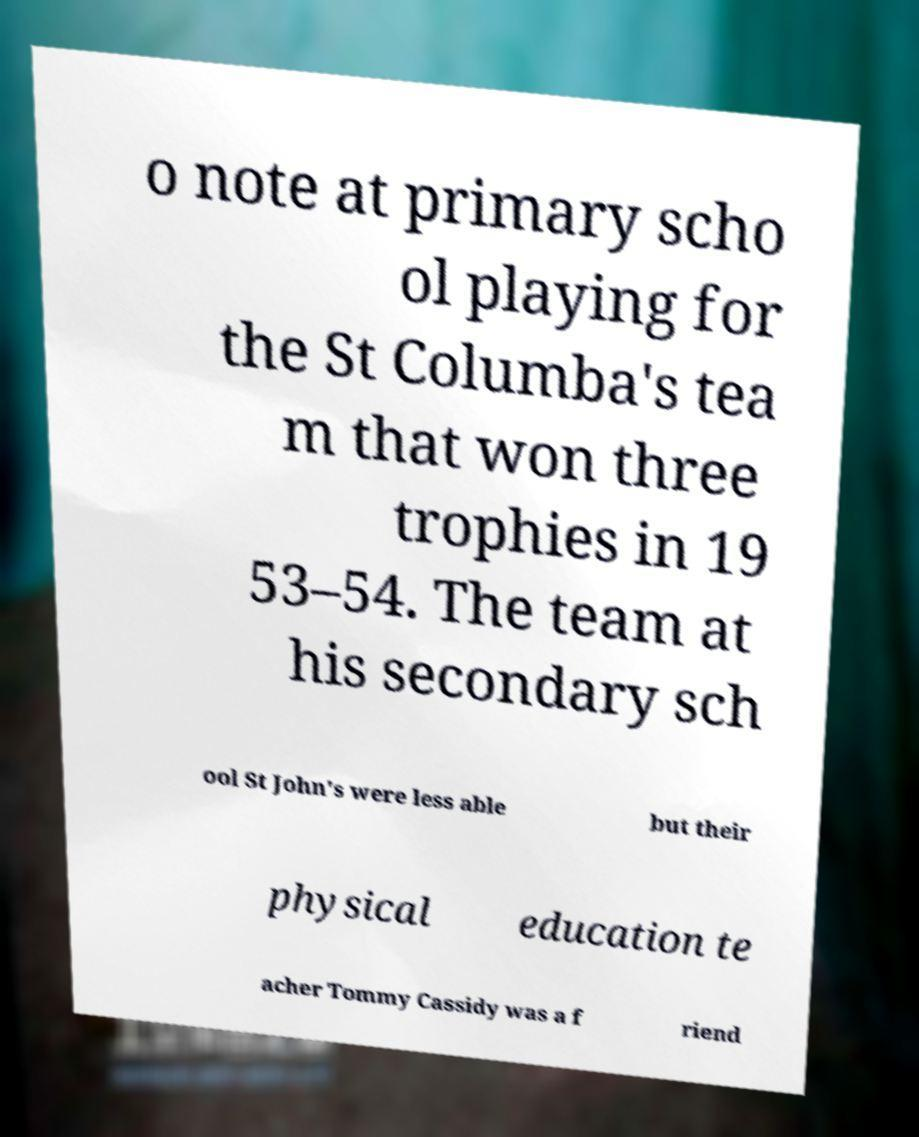For documentation purposes, I need the text within this image transcribed. Could you provide that? o note at primary scho ol playing for the St Columba's tea m that won three trophies in 19 53–54. The team at his secondary sch ool St John's were less able but their physical education te acher Tommy Cassidy was a f riend 